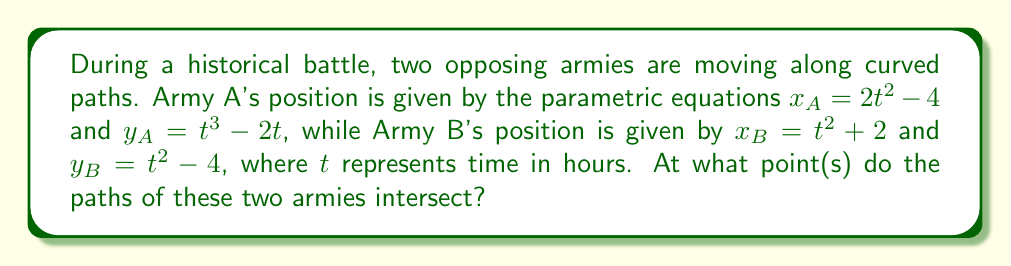Solve this math problem. To find the intersection points of the two parametric curves, we need to solve the system of equations:

$$\begin{cases}
2t^2 - 4 = s^2 + 2 \\
t^3 - 2t = s^2 - 4
\end{cases}$$

Where $t$ is the parameter for Army A and $s$ is the parameter for Army B.

Step 1: From the first equation, solve for $s^2$:
$s^2 = 2t^2 - 6$

Step 2: Substitute this into the second equation:
$t^3 - 2t = (2t^2 - 6) - 4$
$t^3 - 2t = 2t^2 - 10$

Step 3: Rearrange the equation:
$t^3 - 2t^2 + 2t - 10 = 0$

Step 4: Factor out $(t-2)$:
$(t-2)(t^2 + 2) = 0$

Step 5: Solve for $t$:
$t = 2$ or $t^2 = -2$ (which has no real solutions)

Step 6: Calculate the corresponding $s$ value:
When $t = 2$, $s^2 = 2(2)^2 - 6 = 2$
So, $s = \sqrt{2}$ or $s = -\sqrt{2}$

Step 7: Calculate the intersection point:
For Army A: $(x_A, y_A) = (2(2)^2 - 4, 2^3 - 2(2)) = (4, 4)$
For Army B: $(x_B, y_B) = ((\sqrt{2})^2 + 2, (\sqrt{2})^2 - 4) = (4, 4)$

Therefore, the paths of the two armies intersect at the point (4, 4).
Answer: The paths of the two armies intersect at the point (4, 4). 